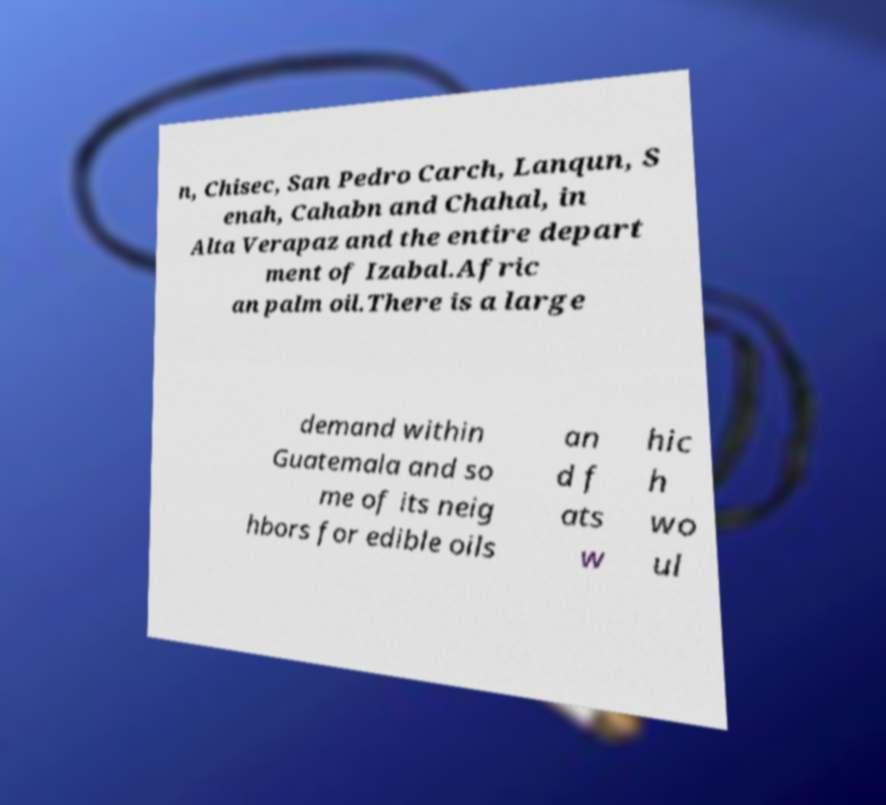Please read and relay the text visible in this image. What does it say? n, Chisec, San Pedro Carch, Lanqun, S enah, Cahabn and Chahal, in Alta Verapaz and the entire depart ment of Izabal.Afric an palm oil.There is a large demand within Guatemala and so me of its neig hbors for edible oils an d f ats w hic h wo ul 